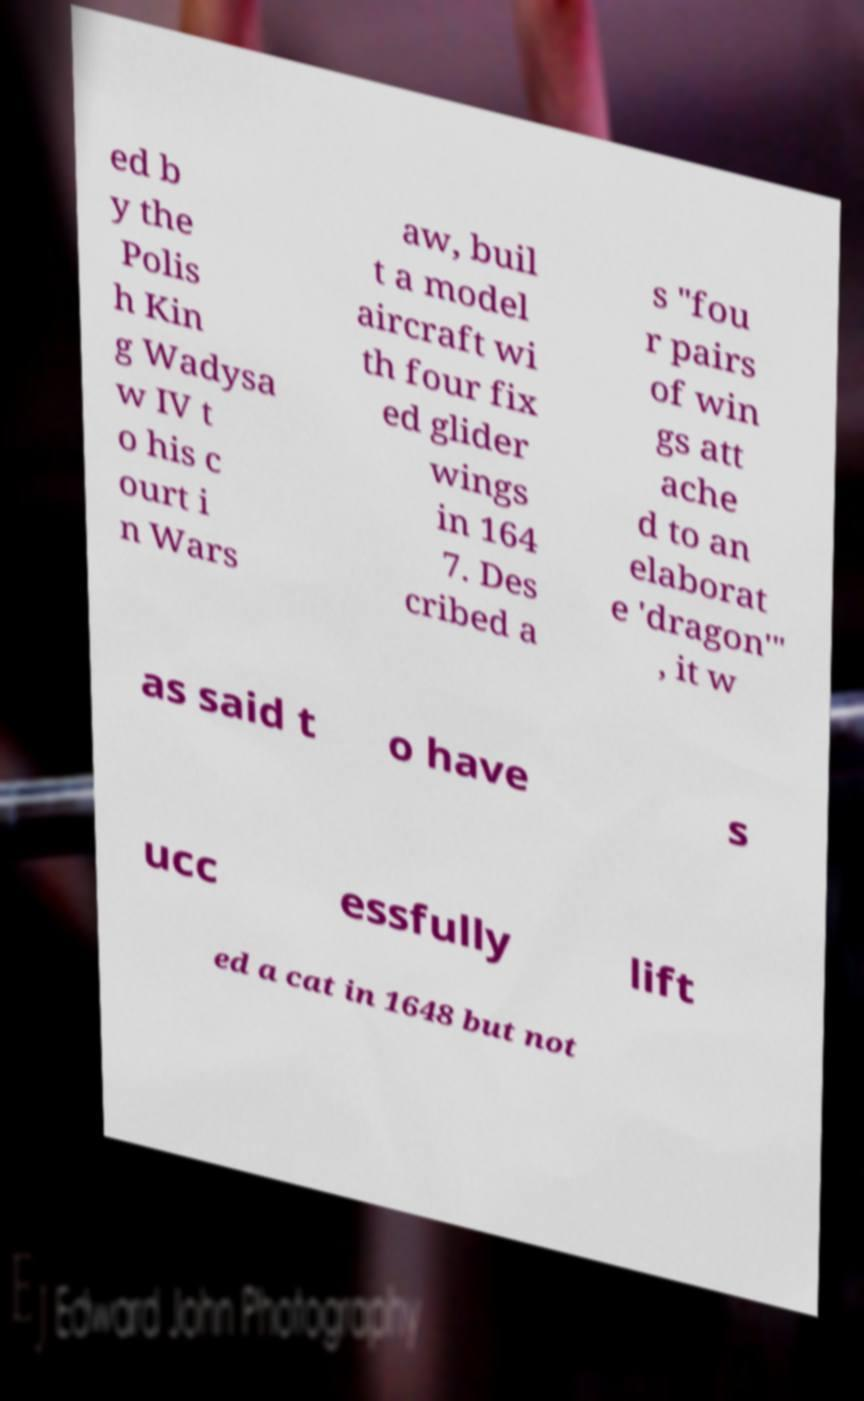Could you extract and type out the text from this image? ed b y the Polis h Kin g Wadysa w IV t o his c ourt i n Wars aw, buil t a model aircraft wi th four fix ed glider wings in 164 7. Des cribed a s "fou r pairs of win gs att ache d to an elaborat e 'dragon'" , it w as said t o have s ucc essfully lift ed a cat in 1648 but not 